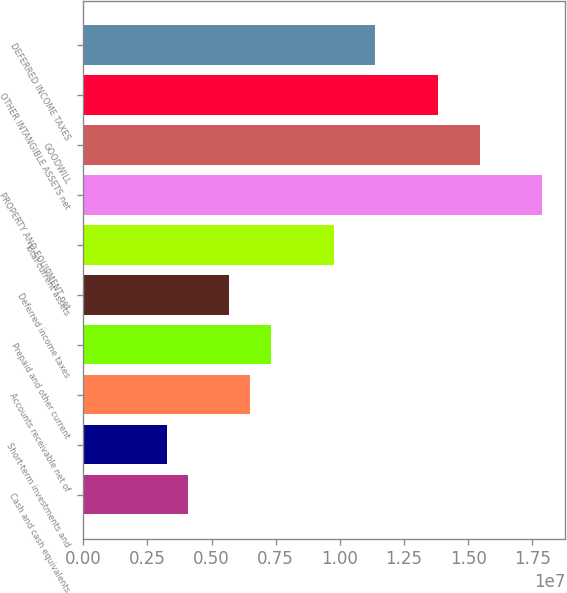<chart> <loc_0><loc_0><loc_500><loc_500><bar_chart><fcel>Cash and cash equivalents<fcel>Short-term investments and<fcel>Accounts receivable net of<fcel>Prepaid and other current<fcel>Deferred income taxes<fcel>Total current assets<fcel>PROPERTY AND EQUIPMENT net<fcel>GOODWILL<fcel>OTHER INTANGIBLE ASSETS net<fcel>DEFERRED INCOME TAXES<nl><fcel>4.06614e+06<fcel>3.25327e+06<fcel>6.50473e+06<fcel>7.31759e+06<fcel>5.69186e+06<fcel>9.75618e+06<fcel>1.78848e+07<fcel>1.54462e+07<fcel>1.38205e+07<fcel>1.13819e+07<nl></chart> 